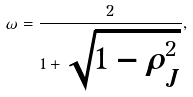<formula> <loc_0><loc_0><loc_500><loc_500>\omega = \frac { 2 } { 1 + \sqrt { 1 - \rho ^ { 2 } _ { J } } } ,</formula> 